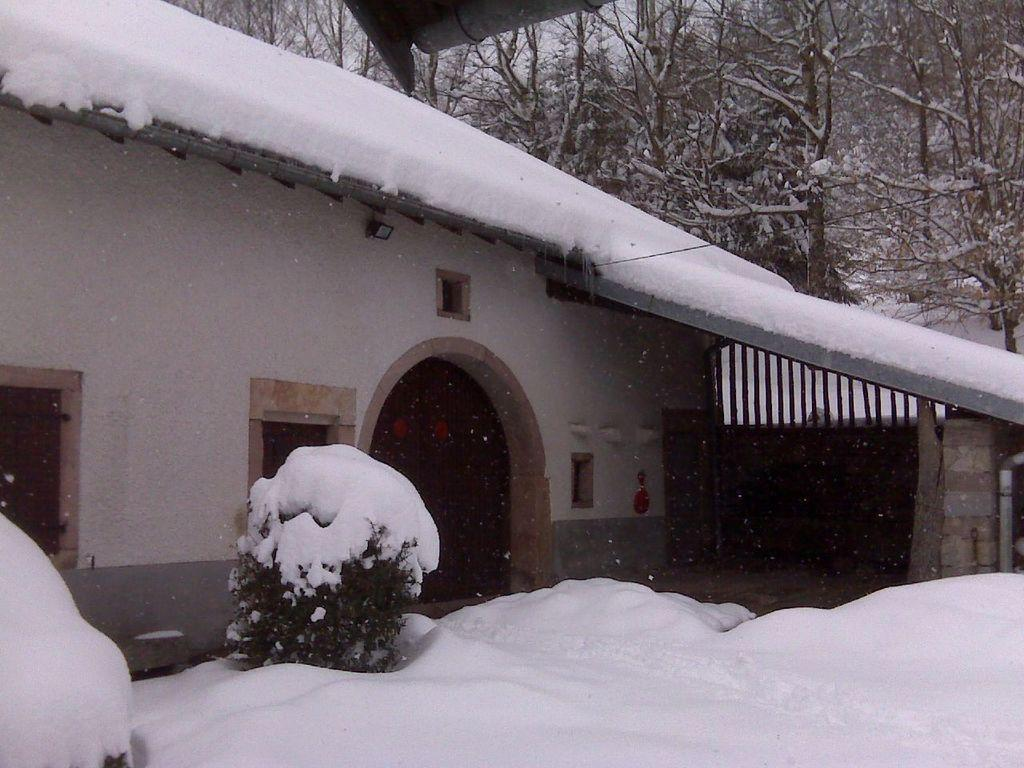What is the main subject in the center of the image? There is a house in the center of the image. What else can be seen in the image besides the house? There are plants in the image, and they are covered with snow. Can you describe the condition of the plants in the image? The plants are covered with snow. What is visible at the bottom of the image? There is snow at the bottom of the image. What can be seen in the background of the image? There are trees in the background of the image. What type of shirt is the throne wearing in the image? There is no throne or shirt present in the image. Can you tell me how many quartz crystals are visible in the image? There are no quartz crystals present in the image. 